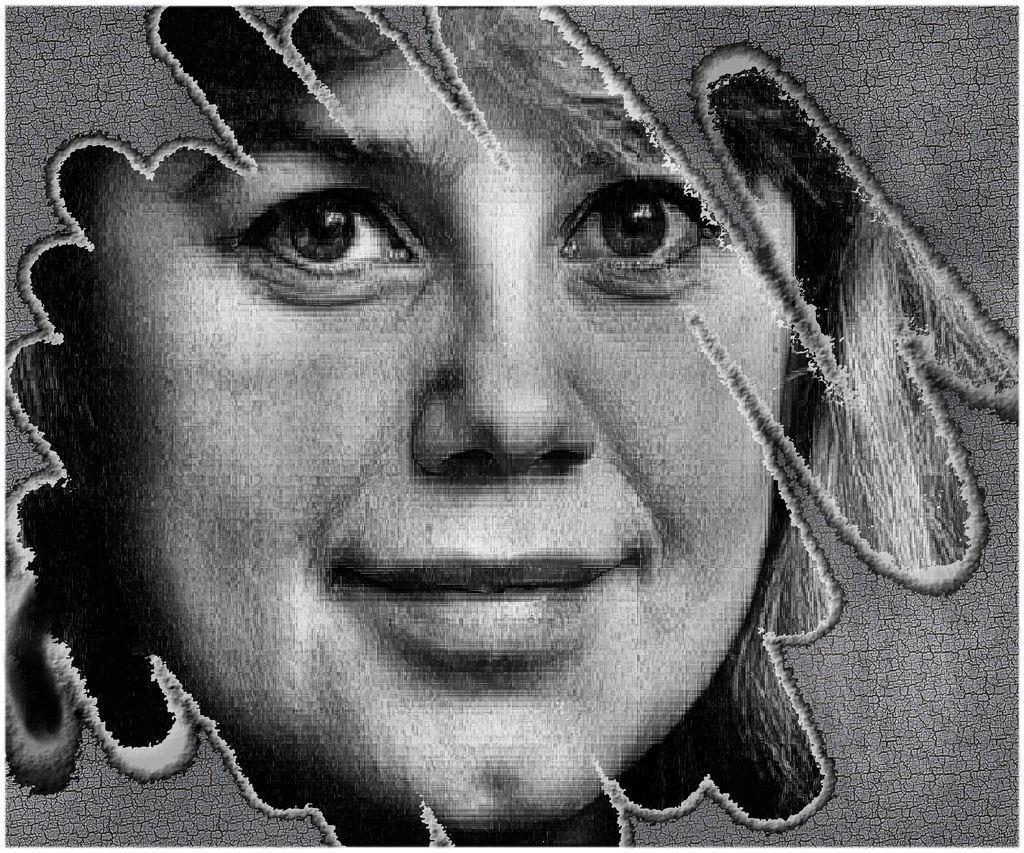Could you give a brief overview of what you see in this image? In this image we can see the edited picture of a person. 